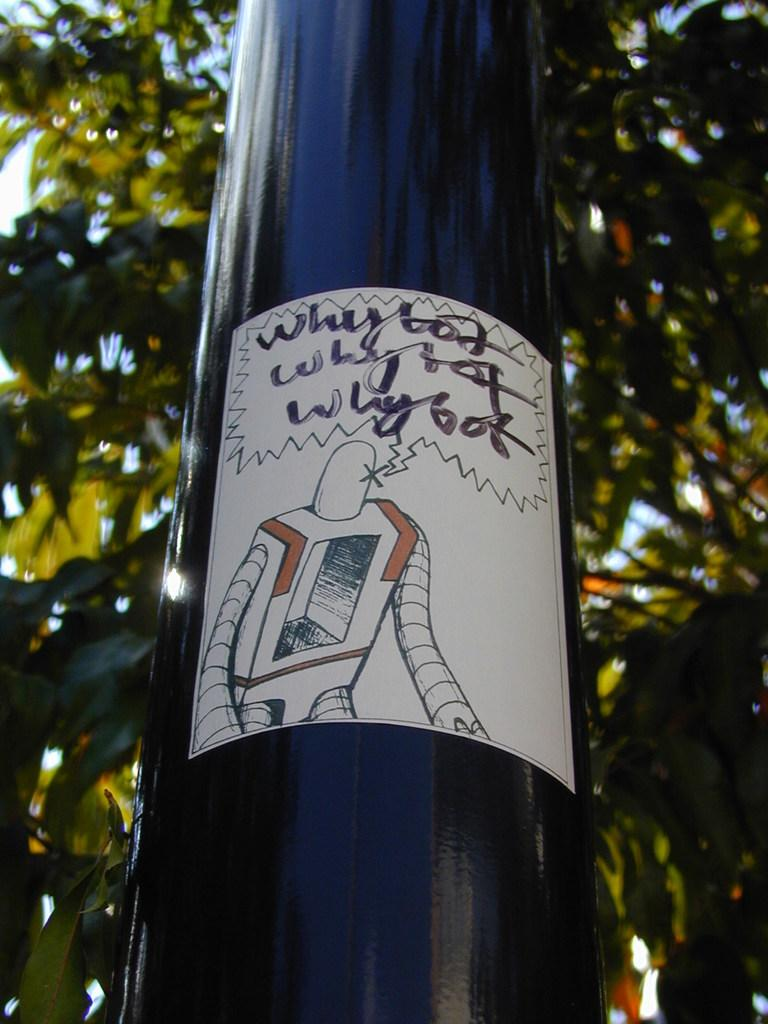<image>
Give a short and clear explanation of the subsequent image. A robot drawing is on a black pole and it says Why bot. 